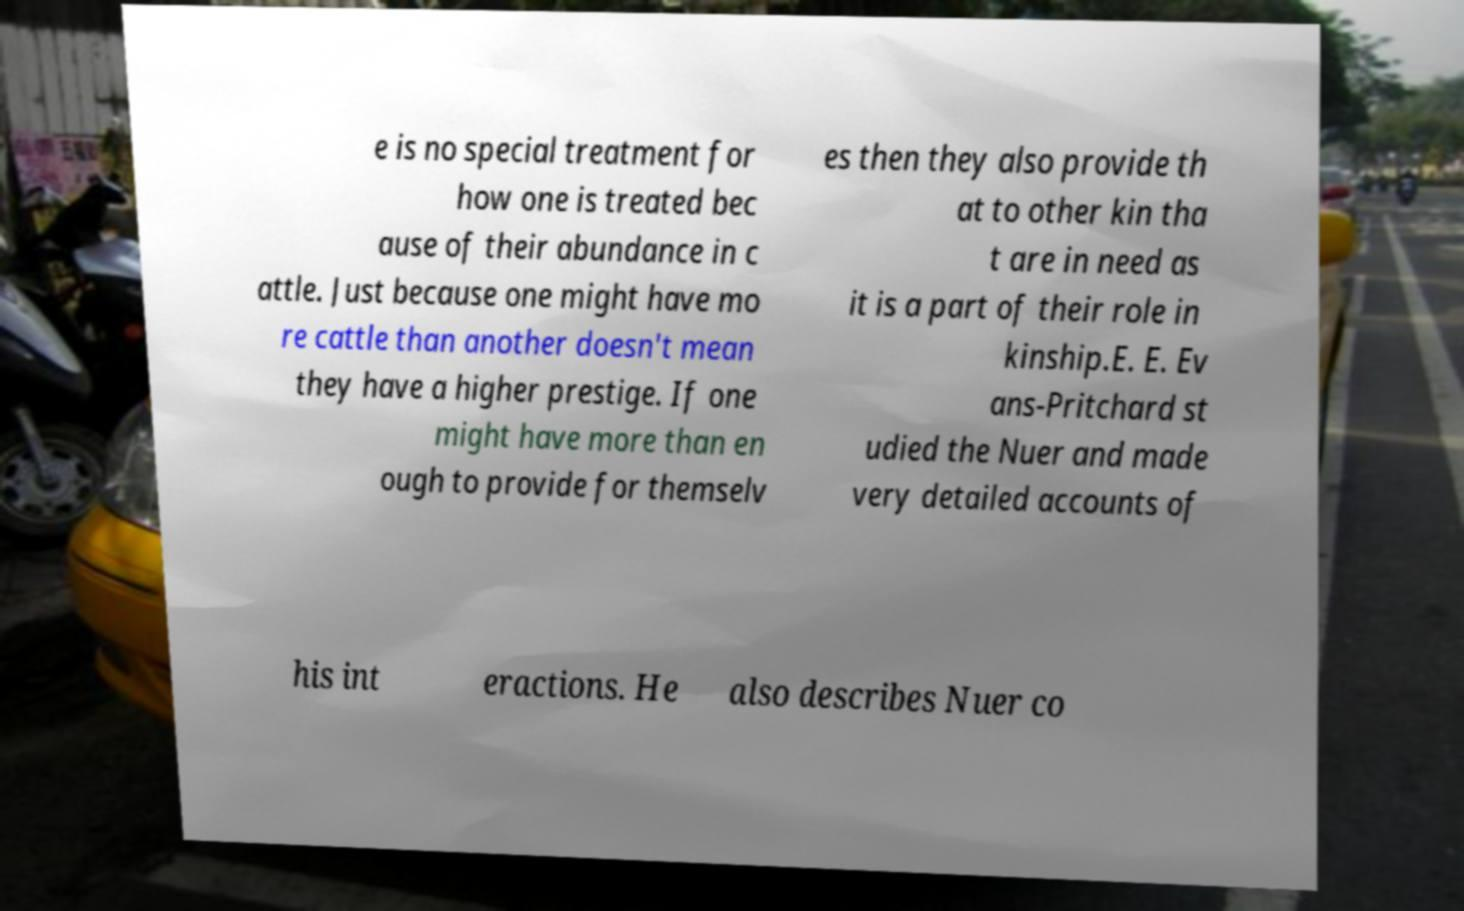Can you read and provide the text displayed in the image?This photo seems to have some interesting text. Can you extract and type it out for me? e is no special treatment for how one is treated bec ause of their abundance in c attle. Just because one might have mo re cattle than another doesn't mean they have a higher prestige. If one might have more than en ough to provide for themselv es then they also provide th at to other kin tha t are in need as it is a part of their role in kinship.E. E. Ev ans-Pritchard st udied the Nuer and made very detailed accounts of his int eractions. He also describes Nuer co 